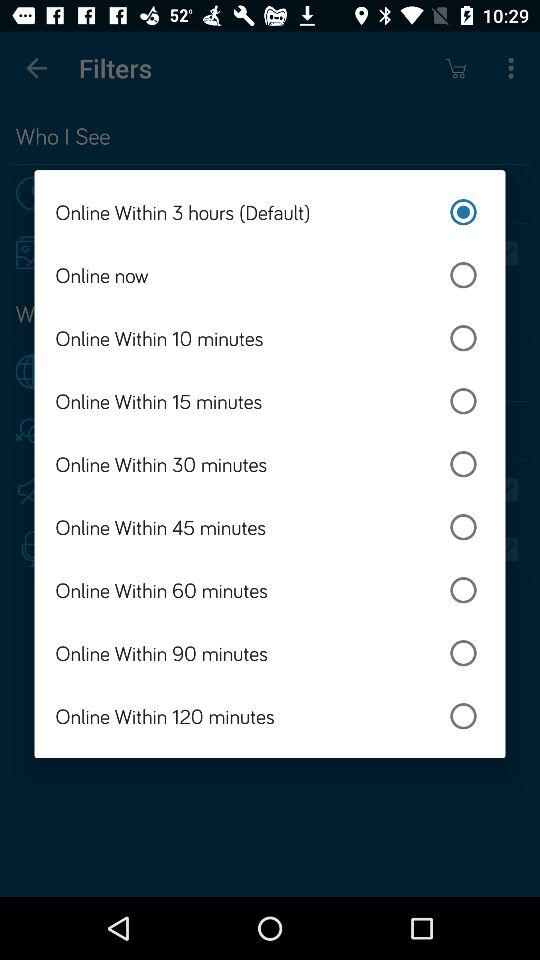How many minutes does the longest available availability option last?
Answer the question using a single word or phrase. 120 